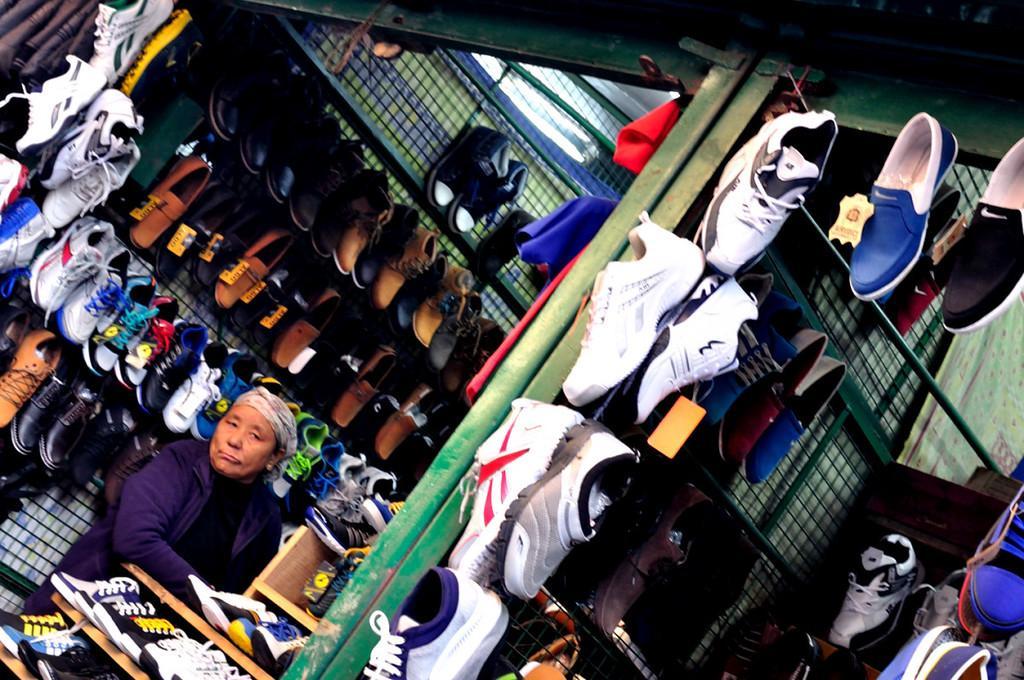Please provide a concise description of this image. In this image we can see shoes hanging on the welded meshes, metal object and on the racks. We can see a person. At the top we can see socks and shutters. 